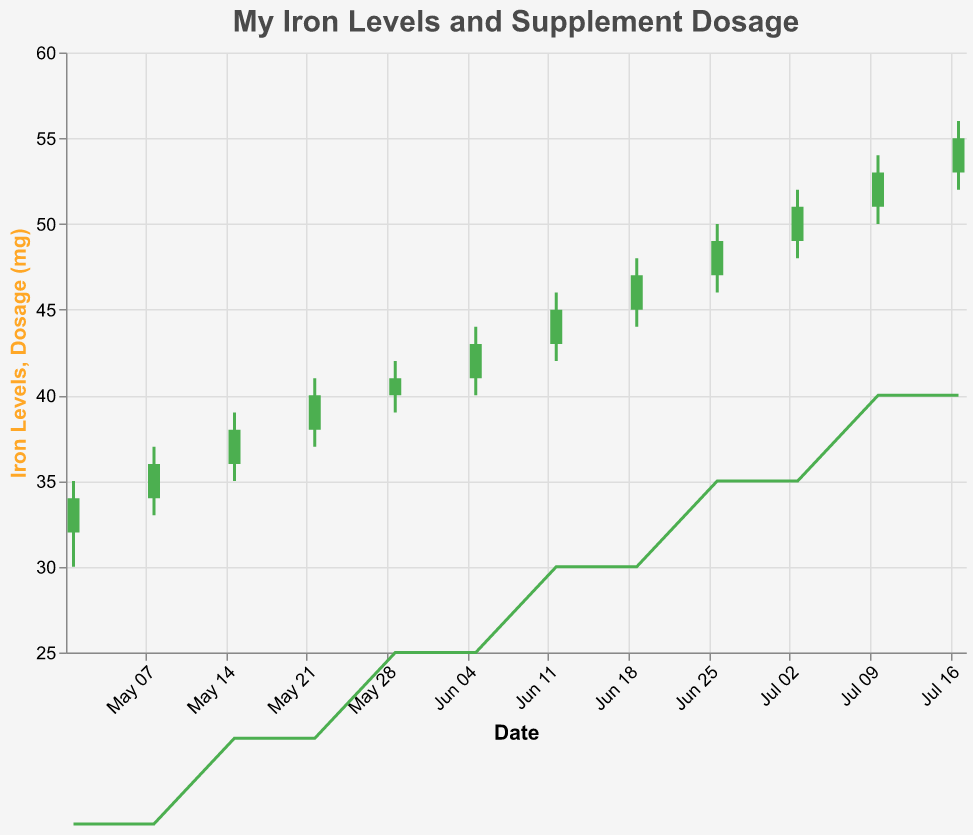What is the title of the chart? The title is displayed at the top of the chart and reads: "My Iron Levels and Supplement Dosage."
Answer: My Iron Levels and Supplement Dosage What does the color green indicate on this chart? The green bars mean that the iron level (Close) at the end of the week was higher than at the start (Open).
Answer: Iron level increased What is the iron level on July 10, 2023? To find this, look at the 'Close' value for the date July 10, 2023, which is 53.
Answer: 53 How much did the dosage increase between May 22 and May 29? Identify the dosage on May 22 (20) and May 29 (25), then subtract the earlier value from the later value: 25 - 20 = 5 mg.
Answer: 5 mg Which week shows the highest high value for iron levels? Look for the highest 'High' value in the chart data, which is 56 on July 17, 2023.
Answer: July 17, 2023 What is the average iron level (Close) over the entire period? Sum all 'Close' values and divide by the number of weeks: (34 + 36 + 38 + 40 + 41 + 43 + 45 + 47 + 49 + 51 + 53 + 55)/12 = 44.
Answer: 44 Did the iron levels decrease in any week after the therapy started? Check if any 'Close' value is less than the 'Open' value for any week. All weeks show an increase or remain the same.
Answer: No What pattern do you observe in iron levels and dosage over the period? Both iron levels and dosage are consistently increasing over time, suggesting a positive response to therapy with dosage adjustments.
Answer: Increasing pattern Is there a direct correlation between dosage and iron levels based on the chart? As dosages increase, iron levels also increase over the observed period, indicating a direct correlation.
Answer: Yes Which week had the lowest Close value, and what was it? Look for the lowest 'Close' value in the chart data, which is 34 on May 1, 2023.
Answer: May 1, 2023, 34 